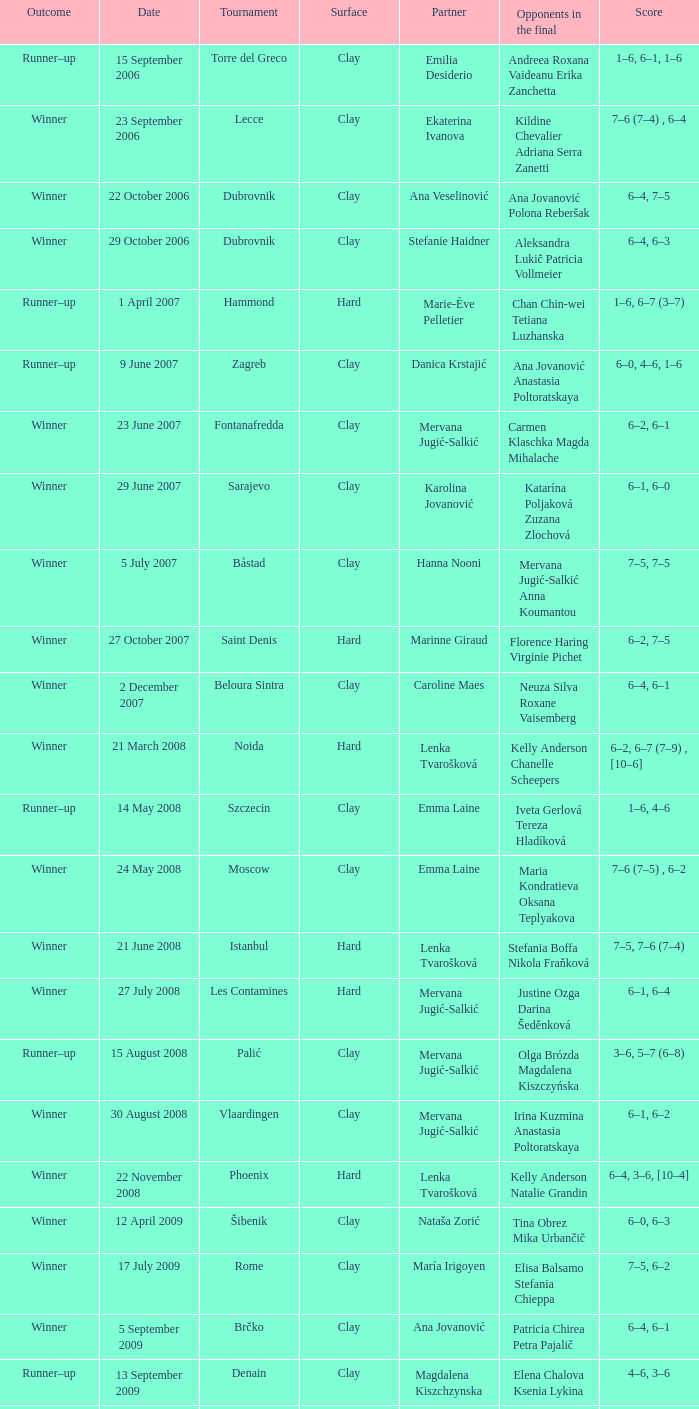Would you mind parsing the complete table? {'header': ['Outcome', 'Date', 'Tournament', 'Surface', 'Partner', 'Opponents in the final', 'Score'], 'rows': [['Runner–up', '15 September 2006', 'Torre del Greco', 'Clay', 'Emilia Desiderio', 'Andreea Roxana Vaideanu Erika Zanchetta', '1–6, 6–1, 1–6'], ['Winner', '23 September 2006', 'Lecce', 'Clay', 'Ekaterina Ivanova', 'Kildine Chevalier Adriana Serra Zanetti', '7–6 (7–4) , 6–4'], ['Winner', '22 October 2006', 'Dubrovnik', 'Clay', 'Ana Veselinović', 'Ana Jovanović Polona Reberšak', '6–4, 7–5'], ['Winner', '29 October 2006', 'Dubrovnik', 'Clay', 'Stefanie Haidner', 'Aleksandra Lukič Patricia Vollmeier', '6–4, 6–3'], ['Runner–up', '1 April 2007', 'Hammond', 'Hard', 'Marie-Ève Pelletier', 'Chan Chin-wei Tetiana Luzhanska', '1–6, 6–7 (3–7)'], ['Runner–up', '9 June 2007', 'Zagreb', 'Clay', 'Danica Krstajić', 'Ana Jovanović Anastasia Poltoratskaya', '6–0, 4–6, 1–6'], ['Winner', '23 June 2007', 'Fontanafredda', 'Clay', 'Mervana Jugić-Salkić', 'Carmen Klaschka Magda Mihalache', '6–2, 6–1'], ['Winner', '29 June 2007', 'Sarajevo', 'Clay', 'Karolina Jovanović', 'Katarína Poljaková Zuzana Zlochová', '6–1, 6–0'], ['Winner', '5 July 2007', 'Båstad', 'Clay', 'Hanna Nooni', 'Mervana Jugić-Salkić Anna Koumantou', '7–5, 7–5'], ['Winner', '27 October 2007', 'Saint Denis', 'Hard', 'Marinne Giraud', 'Florence Haring Virginie Pichet', '6–2, 7–5'], ['Winner', '2 December 2007', 'Beloura Sintra', 'Clay', 'Caroline Maes', 'Neuza Silva Roxane Vaisemberg', '6–4, 6–1'], ['Winner', '21 March 2008', 'Noida', 'Hard', 'Lenka Tvarošková', 'Kelly Anderson Chanelle Scheepers', '6–2, 6–7 (7–9) , [10–6]'], ['Runner–up', '14 May 2008', 'Szczecin', 'Clay', 'Emma Laine', 'Iveta Gerlová Tereza Hladíková', '1–6, 4–6'], ['Winner', '24 May 2008', 'Moscow', 'Clay', 'Emma Laine', 'Maria Kondratieva Oksana Teplyakova', '7–6 (7–5) , 6–2'], ['Winner', '21 June 2008', 'Istanbul', 'Hard', 'Lenka Tvarošková', 'Stefania Boffa Nikola Fraňková', '7–5, 7–6 (7–4)'], ['Winner', '27 July 2008', 'Les Contamines', 'Hard', 'Mervana Jugić-Salkić', 'Justine Ozga Darina Šeděnková', '6–1, 6–4'], ['Runner–up', '15 August 2008', 'Palić', 'Clay', 'Mervana Jugić-Salkić', 'Olga Brózda Magdalena Kiszczyńska', '3–6, 5–7 (6–8)'], ['Winner', '30 August 2008', 'Vlaardingen', 'Clay', 'Mervana Jugić-Salkić', 'Irina Kuzmina Anastasia Poltoratskaya', '6–1, 6–2'], ['Winner', '22 November 2008', 'Phoenix', 'Hard', 'Lenka Tvarošková', 'Kelly Anderson Natalie Grandin', '6–4, 3–6, [10–4]'], ['Winner', '12 April 2009', 'Šibenik', 'Clay', 'Nataša Zorić', 'Tina Obrez Mika Urbančič', '6–0, 6–3'], ['Winner', '17 July 2009', 'Rome', 'Clay', 'María Irigoyen', 'Elisa Balsamo Stefania Chieppa', '7–5, 6–2'], ['Winner', '5 September 2009', 'Brčko', 'Clay', 'Ana Jovanović', 'Patricia Chirea Petra Pajalič', '6–4, 6–1'], ['Runner–up', '13 September 2009', 'Denain', 'Clay', 'Magdalena Kiszchzynska', 'Elena Chalova Ksenia Lykina', '4–6, 3–6'], ['Runner–up', '10 October 2009', 'Podgorica', 'Clay', 'Karolina Jovanović', 'Nicole Clerico Karolina Kosińska', '7–6 (7–4) , 4–6, [4–10]'], ['Runner–up', '25 April 2010', 'Dothan', 'Clay', 'María Irigoyen', 'Alina Jidkova Anastasia Yakimova', '4–6, 2–6'], ['Winner', '12 June 2010', 'Budapest', 'Clay', 'Lenka Wienerová', 'Anna Livadaru Florencia Molinero', '6–4, 6–1'], ['Winner', '2 July 2010', 'Toruń', 'Clay', 'Marija Mirkovic', 'Katarzyna Piter Barbara Sobaszkiewicz', '4–6, 6–2, [10–5]'], ['Winner', '10 July 2010', 'Aschaffenburg', 'Clay', 'Erika Sema', 'Elena Bogdan Andrea Koch Benvenuto', '7–6 (7–4) , 2–6, [10–8]'], ['Runner–up', '6 August 2010', 'Moscow', 'Clay', 'Marija Mirkovic', 'Nadejda Guskova Valeria Solovyeva', '6–7 (5–7) , 3–6'], ['Runner–up', '15 January 2011', 'Glasgow', 'Hard (i)', 'Jasmina Tinjić', 'Ulrikke Eikeri Isabella Shinikova', '4–6, 4–6'], ['Winner', '12 February 2011', 'Antalya', 'Clay', 'Maria Shamayko', 'Sultan Gönen Anna Karavayeva', '6–4, 6–4'], ['Runner–up', '29 April 2011', 'Minsk', 'Hard (i)', 'Nicole Rottmann', 'Lyudmyla Kichenok Nadiya Kichenok', '1–6, 2–6'], ['Winner', '18 June 2011', 'Istanbul', 'Hard', 'Marta Domachowska', 'Daniella Dominikovic Melis Sezer', '6–4, 6–2'], ['Winners', '10 September 2011', 'Saransk', 'Clay', 'Mihaela Buzărnescu', 'Eva Hrdinová Veronika Kapshay', '6–3, 6–1'], ['Runner–up', '19-Mar-2012', 'Antalya', 'Clay', 'Claudia Giovine', 'Evelyn Mayr (ITA) Julia Mayr', '2-6,3-6'], ['Winner', '23-Apr-2012', 'San Severo', 'Clay', 'Anastasia Grymalska', 'Chiara Mendo Giulia Sussarello', '6-2 6-4'], ['Winners', '26 May 2012', 'Timișoara , Romania', 'Clay', 'Andreea Mitu', 'Lina Gjorcheska Dalia Zafirova', '6–1, 6–2'], ['Runner–up', '04-Jun-2012', 'Karshi , UZBEKISTAN', 'Clay', 'Veronika Kapshay', 'Valentyna Ivakhnenko Kateryna Kozlova', '5-7,3-6'], ['Winners', '25-Jun-2012', 'Izmir , TURKEY', 'Hard', 'Ana Bogdan', 'Abbie Myers Melis Sezer', '6-3, 3-0 RET'], ['Runner–up', '25-Jun-2012', 'Mestre , ITA', 'Clay', 'Reka-Luca Jani', 'Mailen Auroux Maria Irigoyen', '7-5,4-6 8-10'], ['Runner–up', '04-Feb-2013', 'Antalya , TURKEY', 'Clay', 'Ana Bogdan', 'Giulia Bruzzone Martina Caregaro', '3-6,6-1 6-10'], ['Winners', '11-Feb-2013', 'Antalya , TURKEY', 'Clay', 'Raluca Elena Platon', 'Ekaterine Gorgodze Sofia Kvatsabaia', '1-6 4-5 RET'], ['Winners', '01-Apr-2013', 'Heraklion , GRE', 'Carpet', 'Vivien Juhaszova', 'Giulia Sussarello Sara Sussarello', '7-5 6-7 (7) 10-4'], ['Winners', '08-Apr-2013', 'Heraklion , GRE', 'Carpet', 'Marina Melnikova', 'Giulia Sussarello Despina Papamichail', '6-1 6-4'], ['Winner', '13 May 2013', 'Balikpapan , Indonesia', 'Hard', 'Naomi Broady', 'Chen Yi Xu Yifan', '6–3, 6–3'], ['Winner', '20 May 2013', 'Tarakan , Indonesia', 'Hard (i)', 'Naomi Broady', 'Tang Haochen Tian Ran', '6–2, 1–6, [10–5]'], ['Runner–up', '03-Jun-2013', 'Karshi , Uzbekıstan', 'Clay', 'Veronika Kapshay', 'Margarita Gasparyan Polina Pekhova', '2-6,1-6'], ['Winner', '16 September 2013', 'Dobrich , Bulgaria', 'Clay', 'Xenia Knoll', 'Isabella Shinikova Dalia Zafirova', '7-5, 7–6(7–5)']]} Who were the opponents in the final at Noida? Kelly Anderson Chanelle Scheepers. 